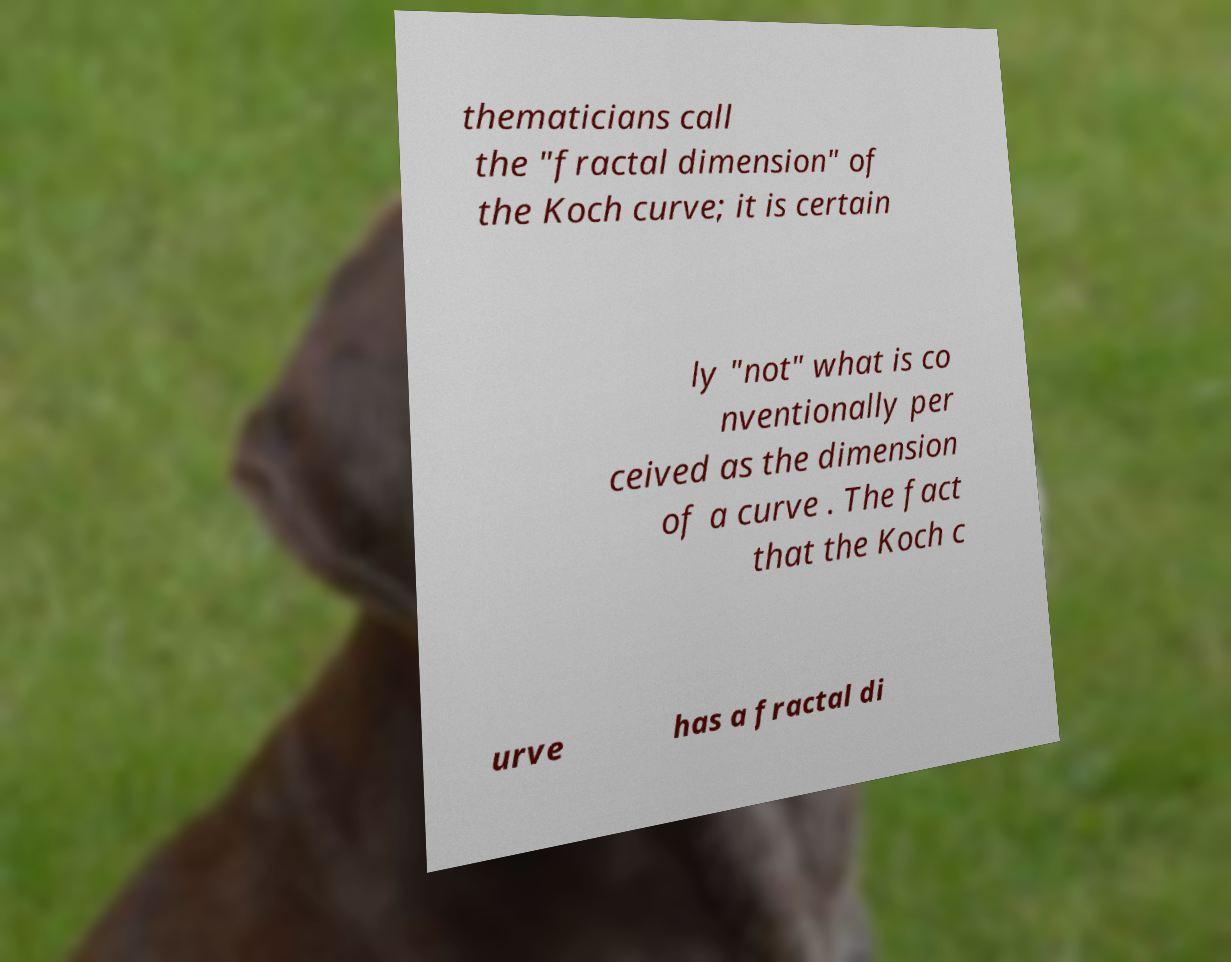There's text embedded in this image that I need extracted. Can you transcribe it verbatim? thematicians call the "fractal dimension" of the Koch curve; it is certain ly "not" what is co nventionally per ceived as the dimension of a curve . The fact that the Koch c urve has a fractal di 